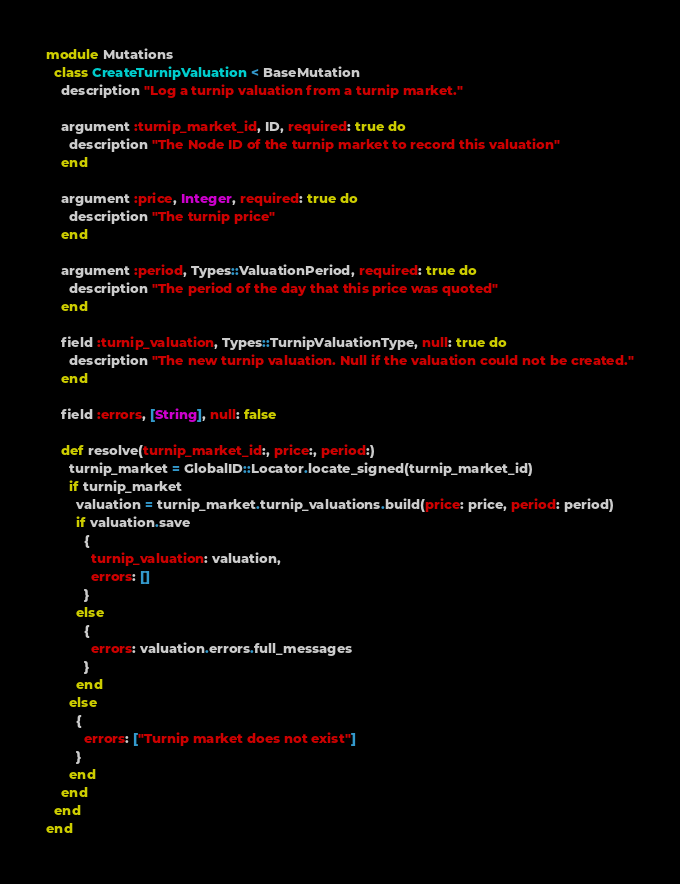Convert code to text. <code><loc_0><loc_0><loc_500><loc_500><_Ruby_>module Mutations
  class CreateTurnipValuation < BaseMutation
    description "Log a turnip valuation from a turnip market."

    argument :turnip_market_id, ID, required: true do
      description "The Node ID of the turnip market to record this valuation"
    end

    argument :price, Integer, required: true do
      description "The turnip price"
    end

    argument :period, Types::ValuationPeriod, required: true do
      description "The period of the day that this price was quoted"
    end

    field :turnip_valuation, Types::TurnipValuationType, null: true do
      description "The new turnip valuation. Null if the valuation could not be created."
    end

    field :errors, [String], null: false

    def resolve(turnip_market_id:, price:, period:)
      turnip_market = GlobalID::Locator.locate_signed(turnip_market_id)
      if turnip_market
        valuation = turnip_market.turnip_valuations.build(price: price, period: period)
        if valuation.save
          {
            turnip_valuation: valuation,
            errors: []
          }
        else
          {
            errors: valuation.errors.full_messages
          }
        end
      else
        {
          errors: ["Turnip market does not exist"]
        }
      end
    end
  end
end
</code> 